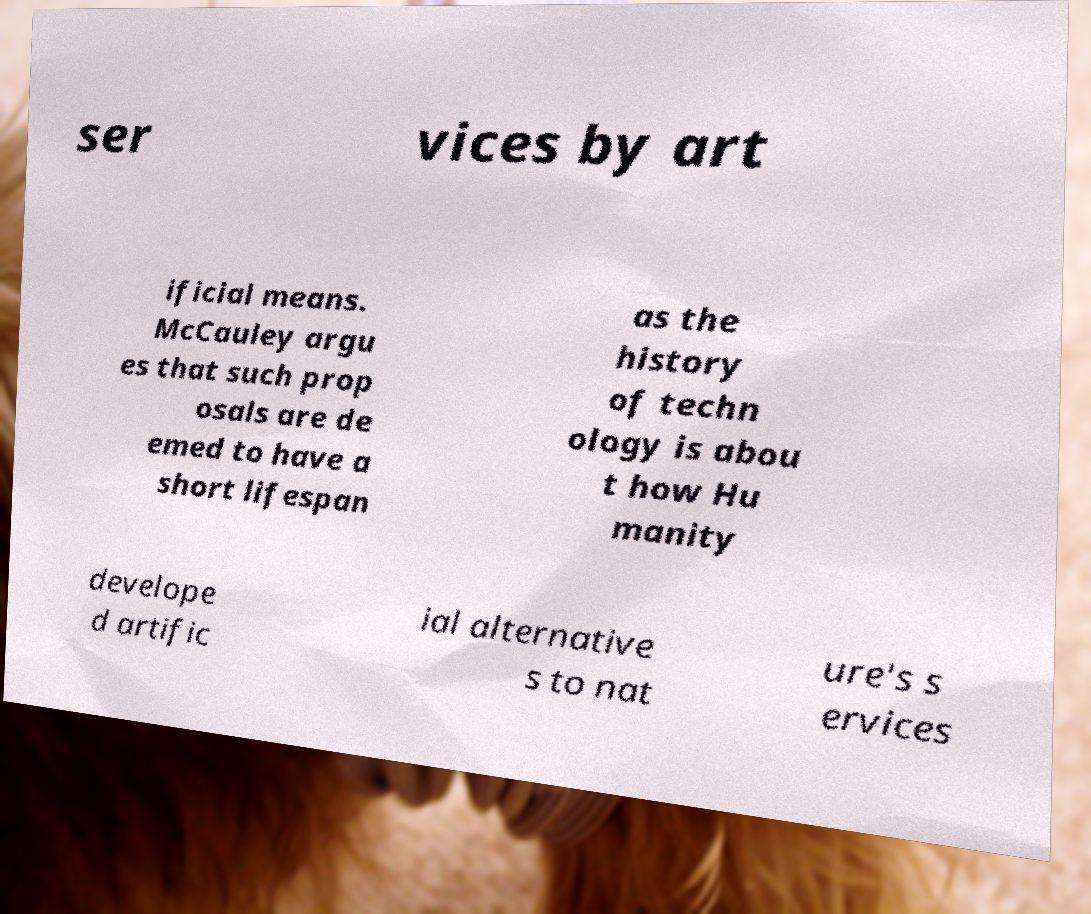There's text embedded in this image that I need extracted. Can you transcribe it verbatim? ser vices by art ificial means. McCauley argu es that such prop osals are de emed to have a short lifespan as the history of techn ology is abou t how Hu manity develope d artific ial alternative s to nat ure's s ervices 